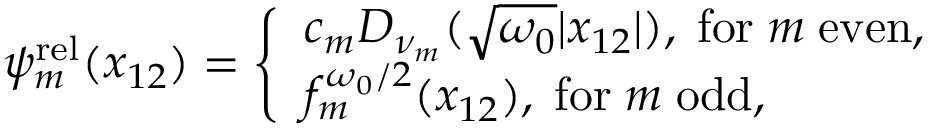Convert formula to latex. <formula><loc_0><loc_0><loc_500><loc_500>\begin{array} { r } { \psi _ { m } ^ { r e l } ( x _ { 1 2 } ) = \left \{ \begin{array} { l l } { c _ { m } D _ { \nu _ { m } } ( \sqrt { \omega _ { 0 } } | x _ { 1 2 } | ) , \, f o r \, m \, e v e n , } \\ { f _ { m } ^ { \omega _ { 0 } / 2 } ( x _ { 1 2 } ) , \, f o r \, m \, o d d , } \end{array} } \end{array}</formula> 